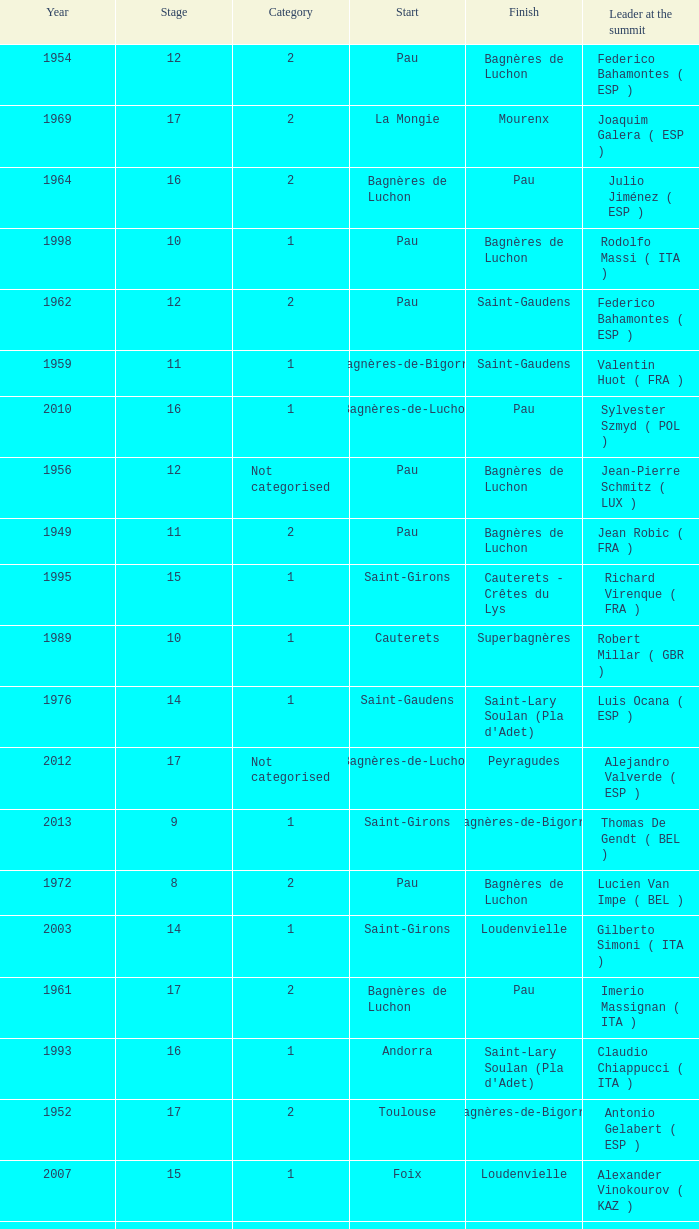What stage has a start of saint-girons in 1988? 15.0. 